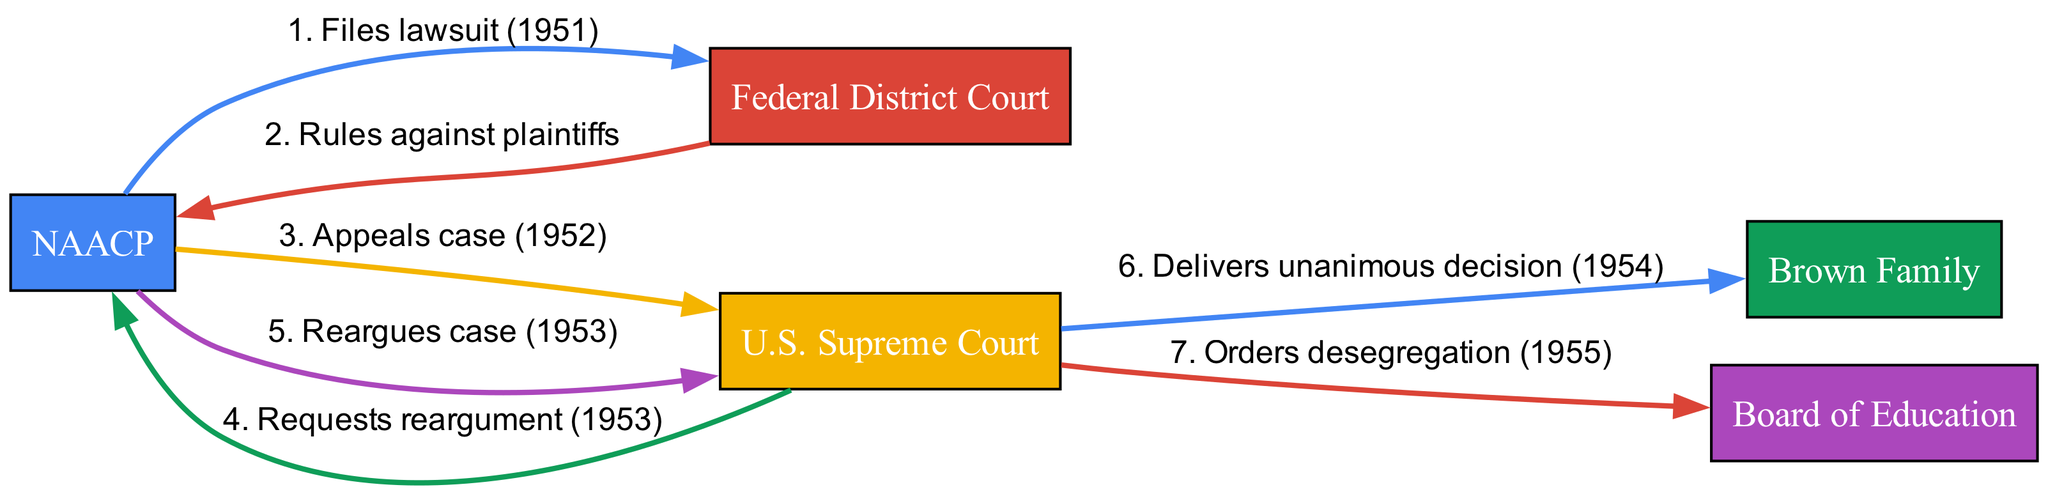What is the first action taken in the sequence? The first action listed in the diagram is "Files lawsuit (1951)", which is initiated by the NAACP directed to the Federal District Court. Therefore, the first action is identified by reviewing the sequence and noting the first step.
Answer: Files lawsuit (1951) How many participants are involved in this sequence? The diagram lists five participants: NAACP, Federal District Court, U.S. Supreme Court, Brown Family, and Board of Education. Counting each unique participant gives a total of five.
Answer: 5 Who does the U.S. Supreme Court deliver a decision to? The U.S. Supreme Court delivers a unanimous decision to the Brown Family as indicated in the sequence. This can be identified directly from the arrow pointing from "U.S. Supreme Court" to "Brown Family" with the associated action.
Answer: Brown Family What action comes after the "Rules against plaintiffs"? Following the action "Rules against plaintiffs" by the Federal District Court, the next action is "Appeals case (1952)" by the NAACP. This can be determined by following the sequential flow of events in the diagram.
Answer: Appeals case (1952) How many actions are taken by the NAACP in the diagram? The NAACP is involved in three actions: "Files lawsuit (1951)", "Appeals case (1952)", and "Reargues case (1953)". Counting these specific actions gives a total of three.
Answer: 3 What decision does the U.S. Supreme Court make in 1954? The U.S. Supreme Court delivers a unanimous decision in 1954 as indicated in the sequence. The specific decision is not stated, but the action outlined is clear in the diagram.
Answer: Delivers unanimous decision Which participant does the U.S. Supreme Court order to desegregate? The U.S. Supreme Court orders the Board of Education to desegregate as noted in the sequence. This relationship can be traced directly from the arrow labeled with the action.
Answer: Board of Education What event is reargued in 1953? The event that is reargued in 1953 is the "case", as referenced by the action "Reargues case (1953)" initiated by the NAACP. This can be directly inferred from the sequence of actions involving the NAACP.
Answer: case What is the last action in the sequence diagram? The last action indicated in the sequence is "Orders desegregation (1955)" from the U.S. Supreme Court to the Board of Education, which marks the end of the sequence. Following the order of actions gives clear insight into the sequence progression.
Answer: Orders desegregation (1955) 